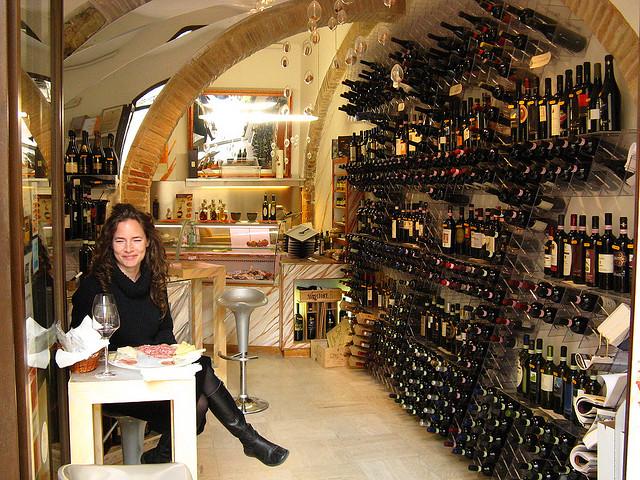Is the woman wearing heels?
Quick response, please. No. What is the person holding?
Keep it brief. Wine glass. What can be purchased at this shop?
Concise answer only. Wine. What is on the wall?
Keep it brief. Wine bottles. Are the instruments on the wall precision instruments?
Short answer required. No. What is in the bottles?
Write a very short answer. Wine. 